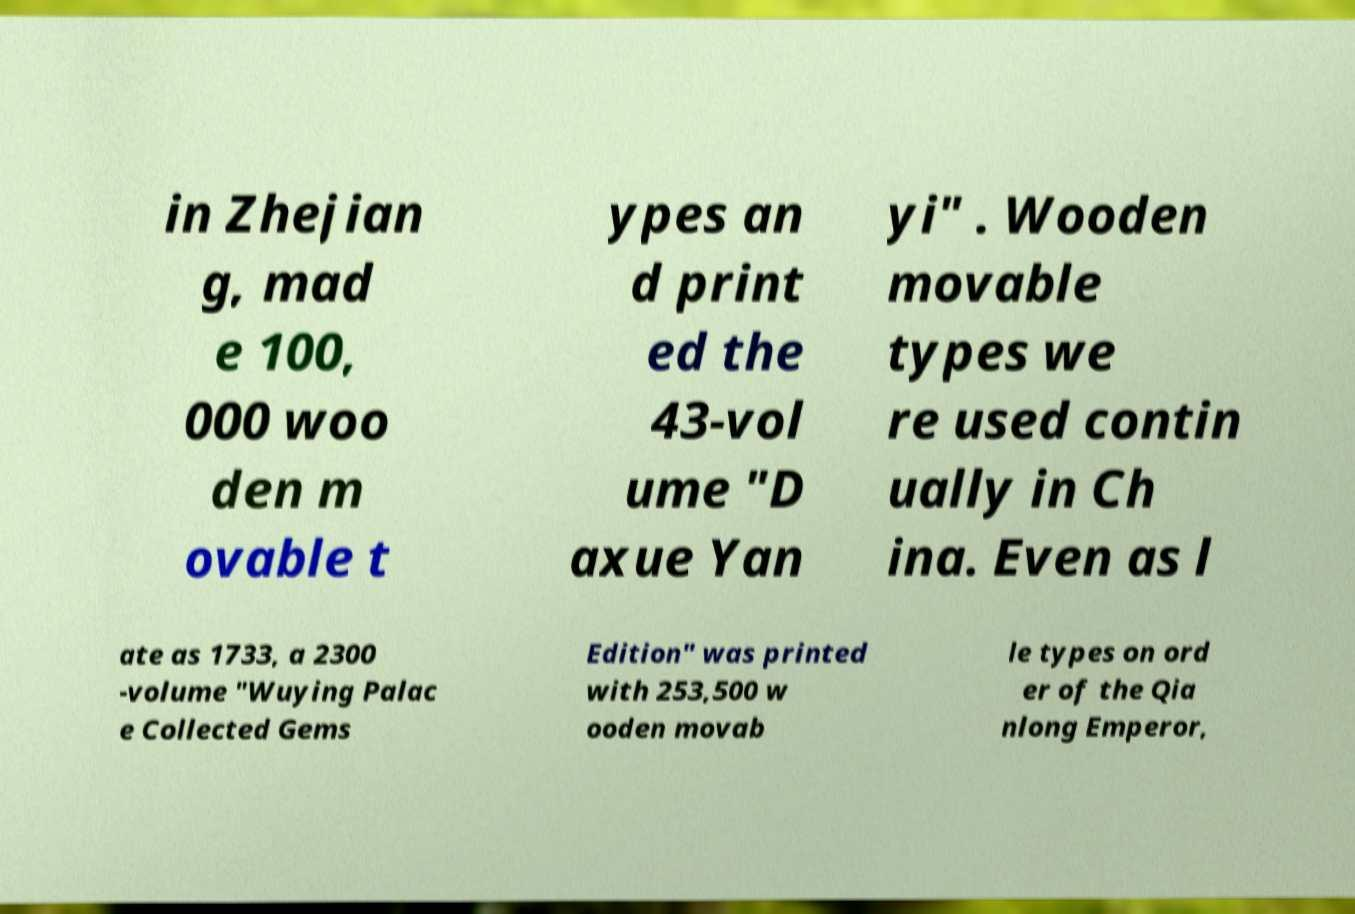Can you accurately transcribe the text from the provided image for me? in Zhejian g, mad e 100, 000 woo den m ovable t ypes an d print ed the 43-vol ume "D axue Yan yi" . Wooden movable types we re used contin ually in Ch ina. Even as l ate as 1733, a 2300 -volume "Wuying Palac e Collected Gems Edition" was printed with 253,500 w ooden movab le types on ord er of the Qia nlong Emperor, 